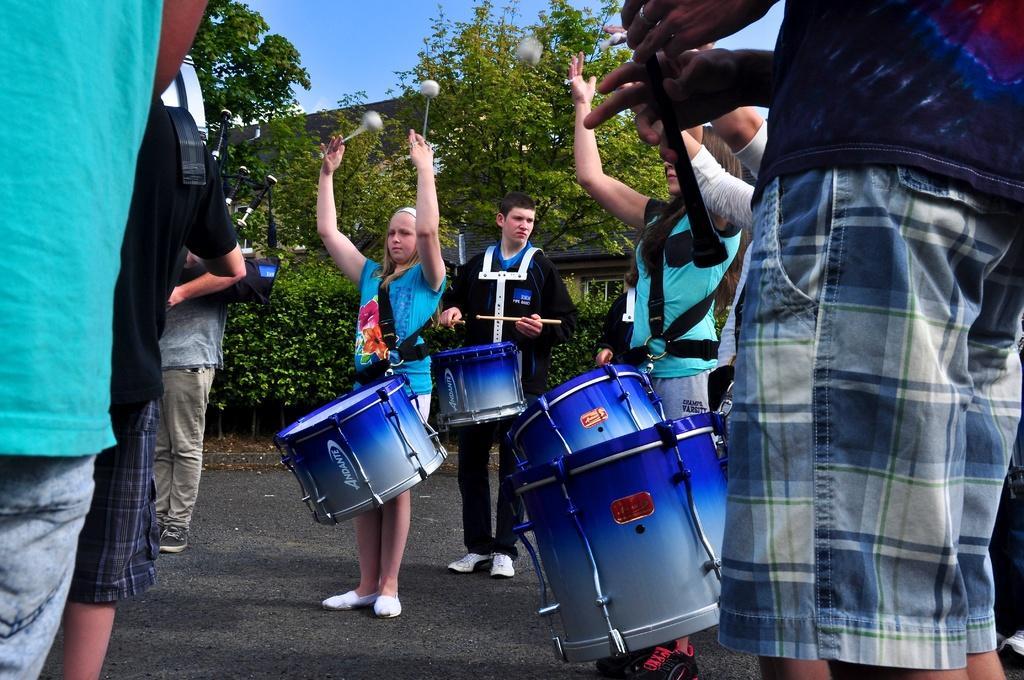Please provide a concise description of this image. This picture Describe as a group of girls and boys are performing the band on the road, In center a girl wearing blue color full t- shirt holding a band stick in her hand and beside there is boy who is wearing black gown and performing the band. On the left side a man wearing grey t- shirt holding a bagpiper in his hand. 